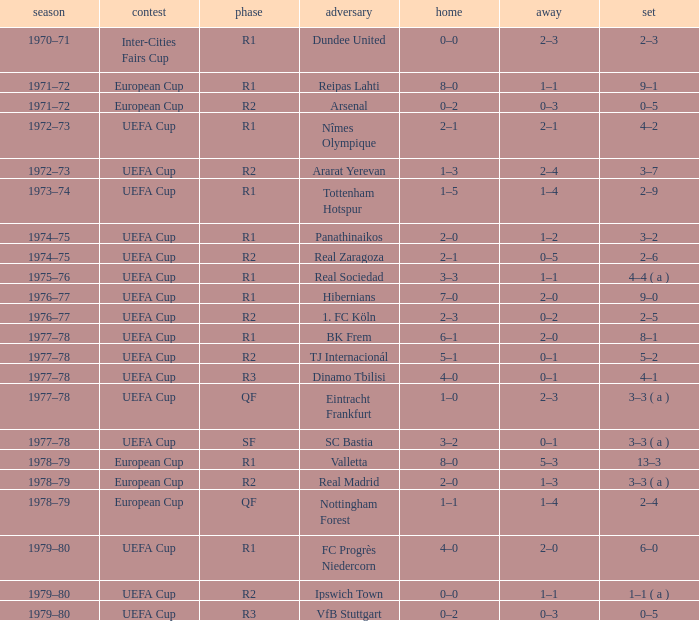Which Series has a Home of 2–0, and an Opponent of panathinaikos? 3–2. 